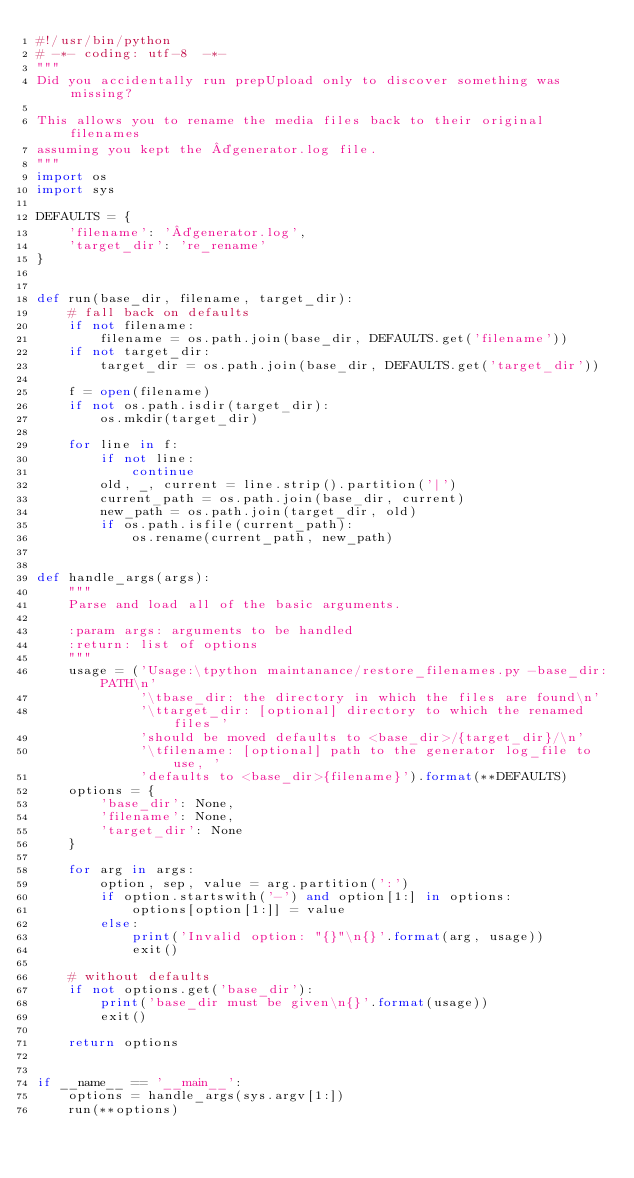Convert code to text. <code><loc_0><loc_0><loc_500><loc_500><_Python_>#!/usr/bin/python
# -*- coding: utf-8  -*-
"""
Did you accidentally run prepUpload only to discover something was missing?

This allows you to rename the media files back to their original filenames
assuming you kept the ¤generator.log file.
"""
import os
import sys

DEFAULTS = {
    'filename': '¤generator.log',
    'target_dir': 're_rename'
}


def run(base_dir, filename, target_dir):
    # fall back on defaults
    if not filename:
        filename = os.path.join(base_dir, DEFAULTS.get('filename'))
    if not target_dir:
        target_dir = os.path.join(base_dir, DEFAULTS.get('target_dir'))

    f = open(filename)
    if not os.path.isdir(target_dir):
        os.mkdir(target_dir)

    for line in f:
        if not line:
            continue
        old, _, current = line.strip().partition('|')
        current_path = os.path.join(base_dir, current)
        new_path = os.path.join(target_dir, old)
        if os.path.isfile(current_path):
            os.rename(current_path, new_path)


def handle_args(args):
    """
    Parse and load all of the basic arguments.

    :param args: arguments to be handled
    :return: list of options
    """
    usage = ('Usage:\tpython maintanance/restore_filenames.py -base_dir:PATH\n'
             '\tbase_dir: the directory in which the files are found\n'
             '\ttarget_dir: [optional] directory to which the renamed files '
             'should be moved defaults to <base_dir>/{target_dir}/\n'
             '\tfilename: [optional] path to the generator log_file to use, '
             'defaults to <base_dir>{filename}').format(**DEFAULTS)
    options = {
        'base_dir': None,
        'filename': None,
        'target_dir': None
    }

    for arg in args:
        option, sep, value = arg.partition(':')
        if option.startswith('-') and option[1:] in options:
            options[option[1:]] = value
        else:
            print('Invalid option: "{}"\n{}'.format(arg, usage))
            exit()

    # without defaults
    if not options.get('base_dir'):
        print('base_dir must be given\n{}'.format(usage))
        exit()

    return options


if __name__ == '__main__':
    options = handle_args(sys.argv[1:])
    run(**options)
</code> 